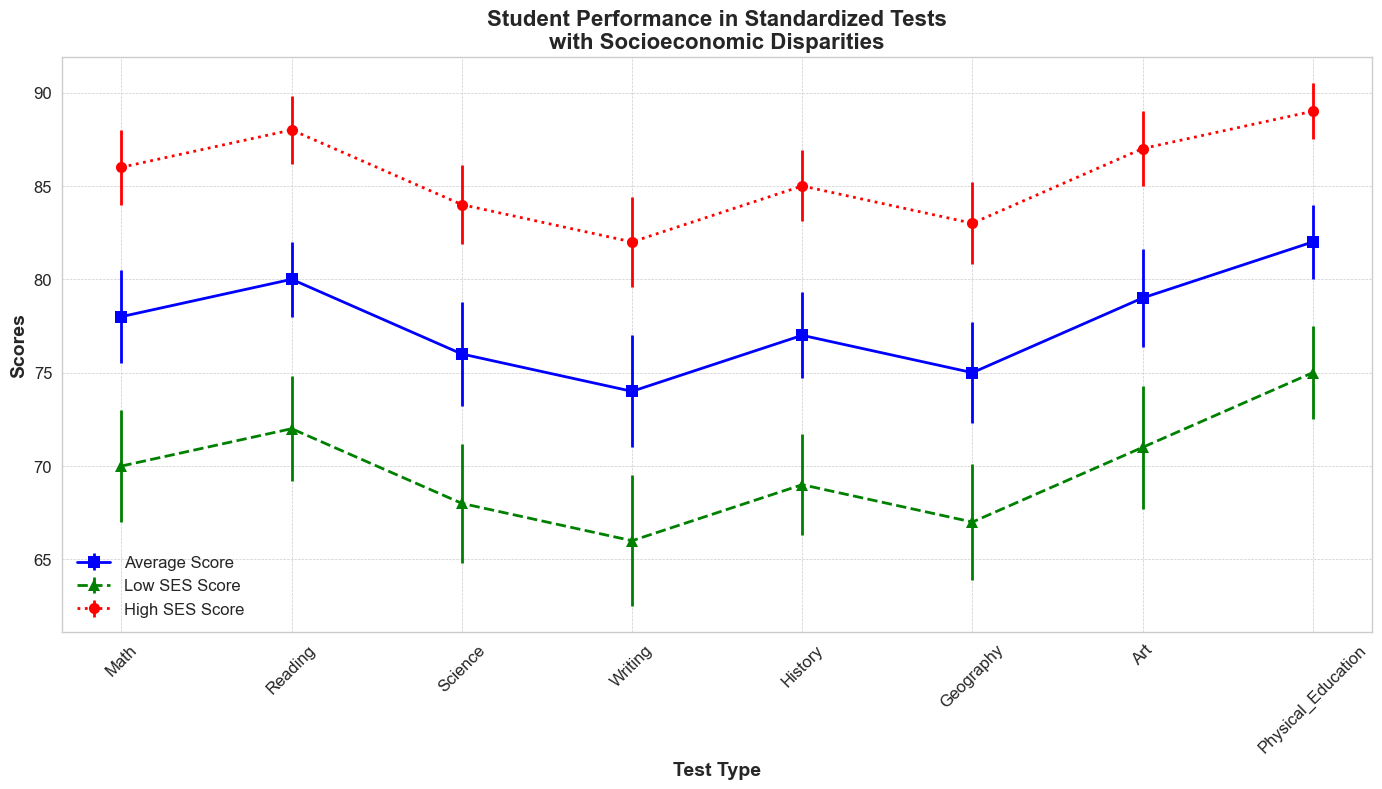What's the highest average score between the three categories for the Math test? The Math test has average scores for the three categories: 78 (Average Score), 70 (Low SES Score), and 86 (High SES Score). The highest score among these is 86, which is the High SES Score.
Answer: 86 Which test shows the largest disparity between Low SES and High SES scores? To find the largest disparity, calculate the difference between High SES and Low SES scores for each test: 
- Math: 86 - 70 = 16
- Reading: 88 - 72 = 16
- Science: 84 - 68 = 16
- Writing: 82 - 66 = 16
- History: 85 - 69 = 16
- Geography: 83 - 67 = 16
- Art: 87 - 71 = 16
- Physical Education: 89 - 75 = 14
All disciplines except Physical Education have a disparity of 16, so any of them could be considered the largest.
Answer: Math, Reading, Science, Writing, History, Geography, Art What is the average error for the Low SES scores in Science and History combined? The Low SES errors for Science and History are 3.2 and 2.7, respectively. (3.2 + 2.7) / 2 = 2.95
Answer: 2.95 Which test has the lowest Low SES score? The scores for Low SES in all tests are: 70 (Math), 72 (Reading), 68 (Science), 66 (Writing), 69 (History), 67 (Geography), 71 (Art), and 75 (Physical Education). The lowest Low SES score is 66 in Writing.
Answer: Writing Do any tests show a visual overlap in error bars between Low SES and High SES scores? Visually inspecting the error bars of each test for Low SES and High SES, we check if the error ranges overlap. For example, in Math, the Low SES score is 70 ± 3 (range 67 to 73), and the High SES score is 86 ± 2 (range 84 to 88). Since there is no overlap, this process is repeated for each test. None of the tests show overlap.
Answer: No 